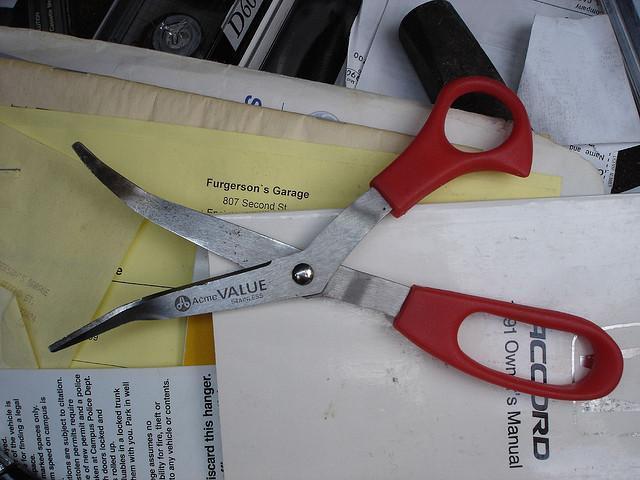How many people are playing?
Give a very brief answer. 0. 